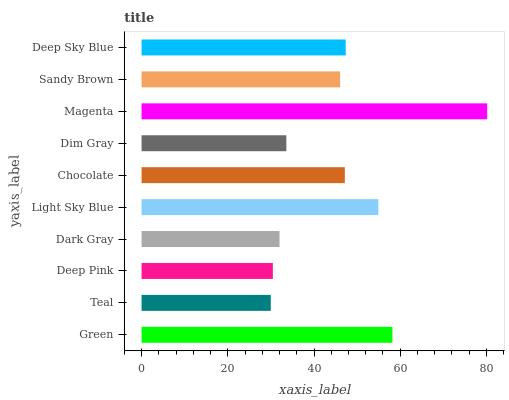Is Teal the minimum?
Answer yes or no. Yes. Is Magenta the maximum?
Answer yes or no. Yes. Is Deep Pink the minimum?
Answer yes or no. No. Is Deep Pink the maximum?
Answer yes or no. No. Is Deep Pink greater than Teal?
Answer yes or no. Yes. Is Teal less than Deep Pink?
Answer yes or no. Yes. Is Teal greater than Deep Pink?
Answer yes or no. No. Is Deep Pink less than Teal?
Answer yes or no. No. Is Chocolate the high median?
Answer yes or no. Yes. Is Sandy Brown the low median?
Answer yes or no. Yes. Is Deep Pink the high median?
Answer yes or no. No. Is Magenta the low median?
Answer yes or no. No. 